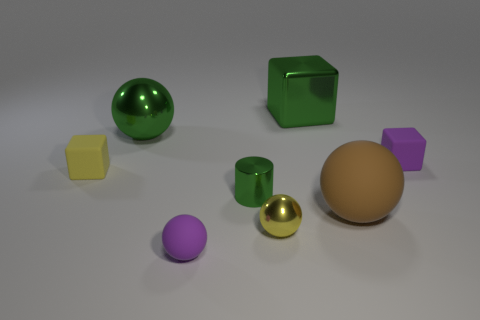Are there any shapes here that are not either a sphere or a cube? Yes, there is one object that is neither a sphere nor a cube - it's a brown egg-shaped object. 